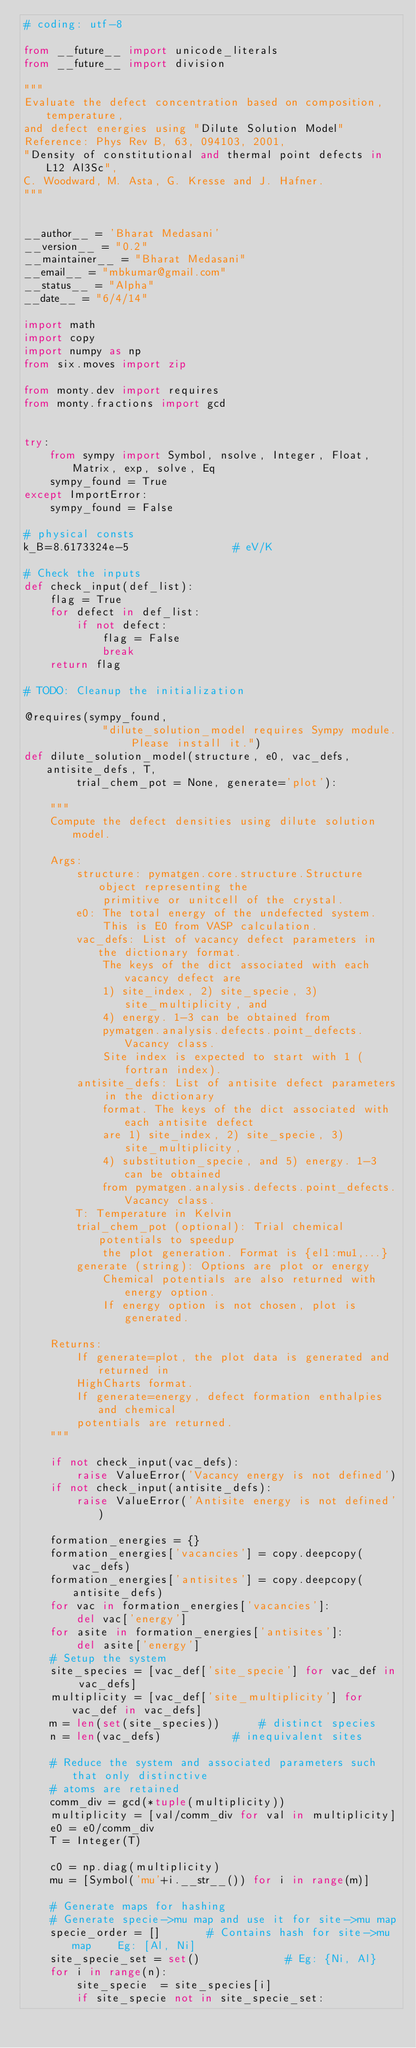<code> <loc_0><loc_0><loc_500><loc_500><_Python_># coding: utf-8

from __future__ import unicode_literals
from __future__ import division

"""
Evaluate the defect concentration based on composition, temperature,
and defect energies using "Dilute Solution Model"
Reference: Phys Rev B, 63, 094103, 2001,
"Density of constitutional and thermal point defects in L12 Al3Sc",
C. Woodward, M. Asta, G. Kresse and J. Hafner.
"""


__author__ = 'Bharat Medasani'
__version__ = "0.2"
__maintainer__ = "Bharat Medasani"
__email__ = "mbkumar@gmail.com"
__status__ = "Alpha"
__date__ = "6/4/14"

import math
import copy
import numpy as np
from six.moves import zip

from monty.dev import requires
from monty.fractions import gcd


try:
    from sympy import Symbol, nsolve, Integer, Float, Matrix, exp, solve, Eq
    sympy_found = True
except ImportError:
    sympy_found = False

# physical consts
k_B=8.6173324e-5                # eV/K

# Check the inputs
def check_input(def_list):
    flag = True
    for defect in def_list:
        if not defect:
            flag = False
            break
    return flag

# TODO: Cleanup the initialization

@requires(sympy_found,
            "dilute_solution_model requires Sympy module. Please install it.")
def dilute_solution_model(structure, e0, vac_defs, antisite_defs, T,
        trial_chem_pot = None, generate='plot'):

    """
    Compute the defect densities using dilute solution model.

    Args:
        structure: pymatgen.core.structure.Structure object representing the
            primitive or unitcell of the crystal.
        e0: The total energy of the undefected system.
            This is E0 from VASP calculation.
        vac_defs: List of vacancy defect parameters in the dictionary format.
            The keys of the dict associated with each vacancy defect are
            1) site_index, 2) site_specie, 3) site_multiplicity, and
            4) energy. 1-3 can be obtained from
            pymatgen.analysis.defects.point_defects.Vacancy class.
            Site index is expected to start with 1 (fortran index).
        antisite_defs: List of antisite defect parameters in the dictionary
            format. The keys of the dict associated with each antisite defect
            are 1) site_index, 2) site_specie, 3) site_multiplicity,
            4) substitution_specie, and 5) energy. 1-3 can be obtained
            from pymatgen.analysis.defects.point_defects.Vacancy class.
        T: Temperature in Kelvin
        trial_chem_pot (optional): Trial chemical potentials to speedup
            the plot generation. Format is {el1:mu1,...}
        generate (string): Options are plot or energy
            Chemical potentials are also returned with energy option.
            If energy option is not chosen, plot is generated.

    Returns:
        If generate=plot, the plot data is generated and returned in
        HighCharts format.
        If generate=energy, defect formation enthalpies and chemical
        potentials are returned.
    """

    if not check_input(vac_defs):
        raise ValueError('Vacancy energy is not defined')
    if not check_input(antisite_defs):
        raise ValueError('Antisite energy is not defined')

    formation_energies = {}
    formation_energies['vacancies'] = copy.deepcopy(vac_defs)
    formation_energies['antisites'] = copy.deepcopy(antisite_defs)
    for vac in formation_energies['vacancies']:
        del vac['energy']
    for asite in formation_energies['antisites']:
        del asite['energy']
    # Setup the system
    site_species = [vac_def['site_specie'] for vac_def in vac_defs]
    multiplicity = [vac_def['site_multiplicity'] for vac_def in vac_defs]
    m = len(set(site_species))      # distinct species
    n = len(vac_defs)           # inequivalent sites

    # Reduce the system and associated parameters such that only distinctive
    # atoms are retained
    comm_div = gcd(*tuple(multiplicity))
    multiplicity = [val/comm_div for val in multiplicity]
    e0 = e0/comm_div
    T = Integer(T)

    c0 = np.diag(multiplicity)
    mu = [Symbol('mu'+i.__str__()) for i in range(m)]

    # Generate maps for hashing
    # Generate specie->mu map and use it for site->mu map
    specie_order = []       # Contains hash for site->mu map    Eg: [Al, Ni]
    site_specie_set = set()             # Eg: {Ni, Al}
    for i in range(n):
        site_specie  = site_species[i]
        if site_specie not in site_specie_set:</code> 